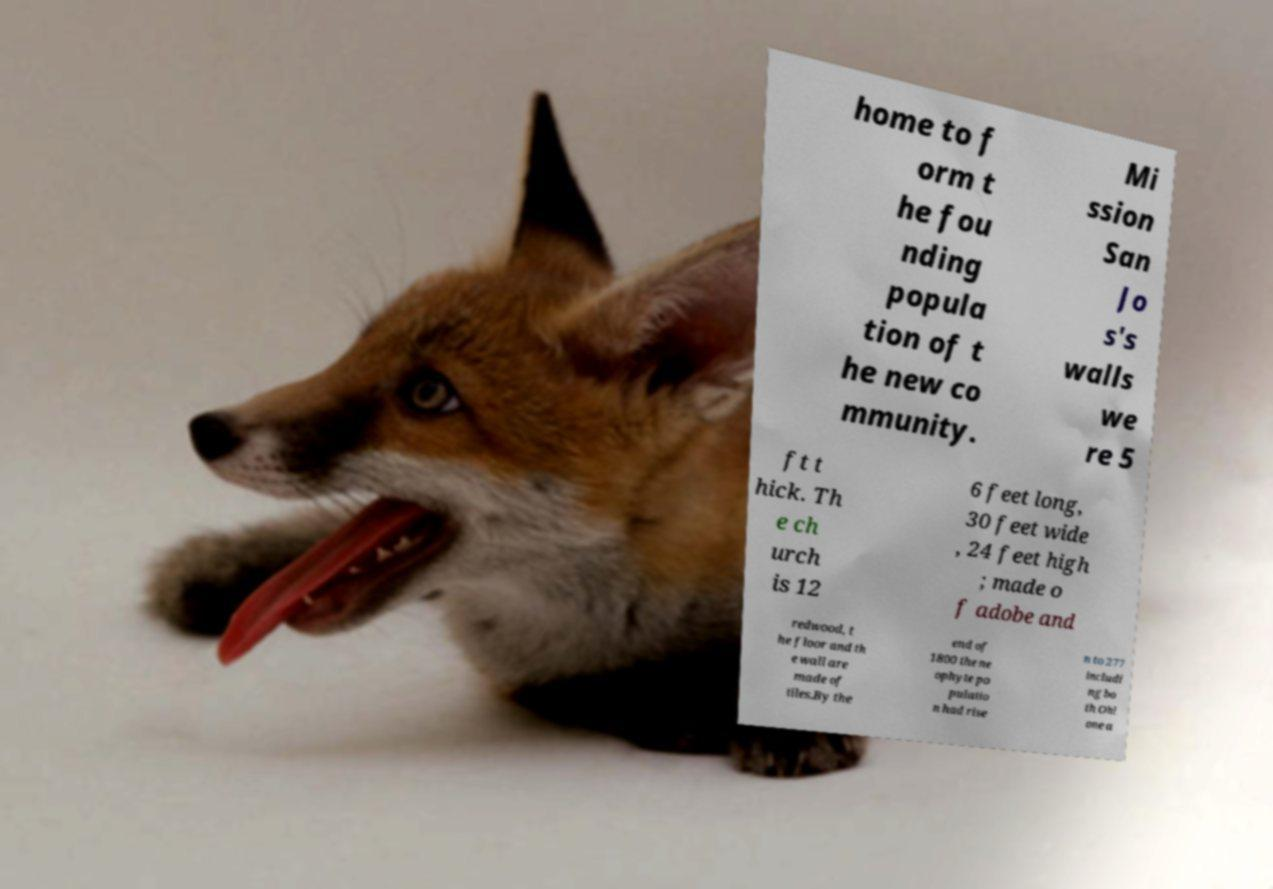Can you read and provide the text displayed in the image?This photo seems to have some interesting text. Can you extract and type it out for me? home to f orm t he fou nding popula tion of t he new co mmunity. Mi ssion San Jo s's walls we re 5 ft t hick. Th e ch urch is 12 6 feet long, 30 feet wide , 24 feet high ; made o f adobe and redwood, t he floor and th e wall are made of tiles.By the end of 1800 the ne ophyte po pulatio n had rise n to 277 includi ng bo th Ohl one a 